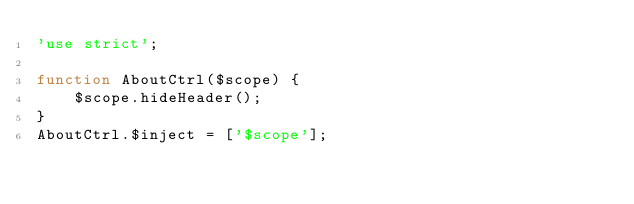<code> <loc_0><loc_0><loc_500><loc_500><_JavaScript_>'use strict';

function AboutCtrl($scope) {
    $scope.hideHeader();
}
AboutCtrl.$inject = ['$scope'];</code> 